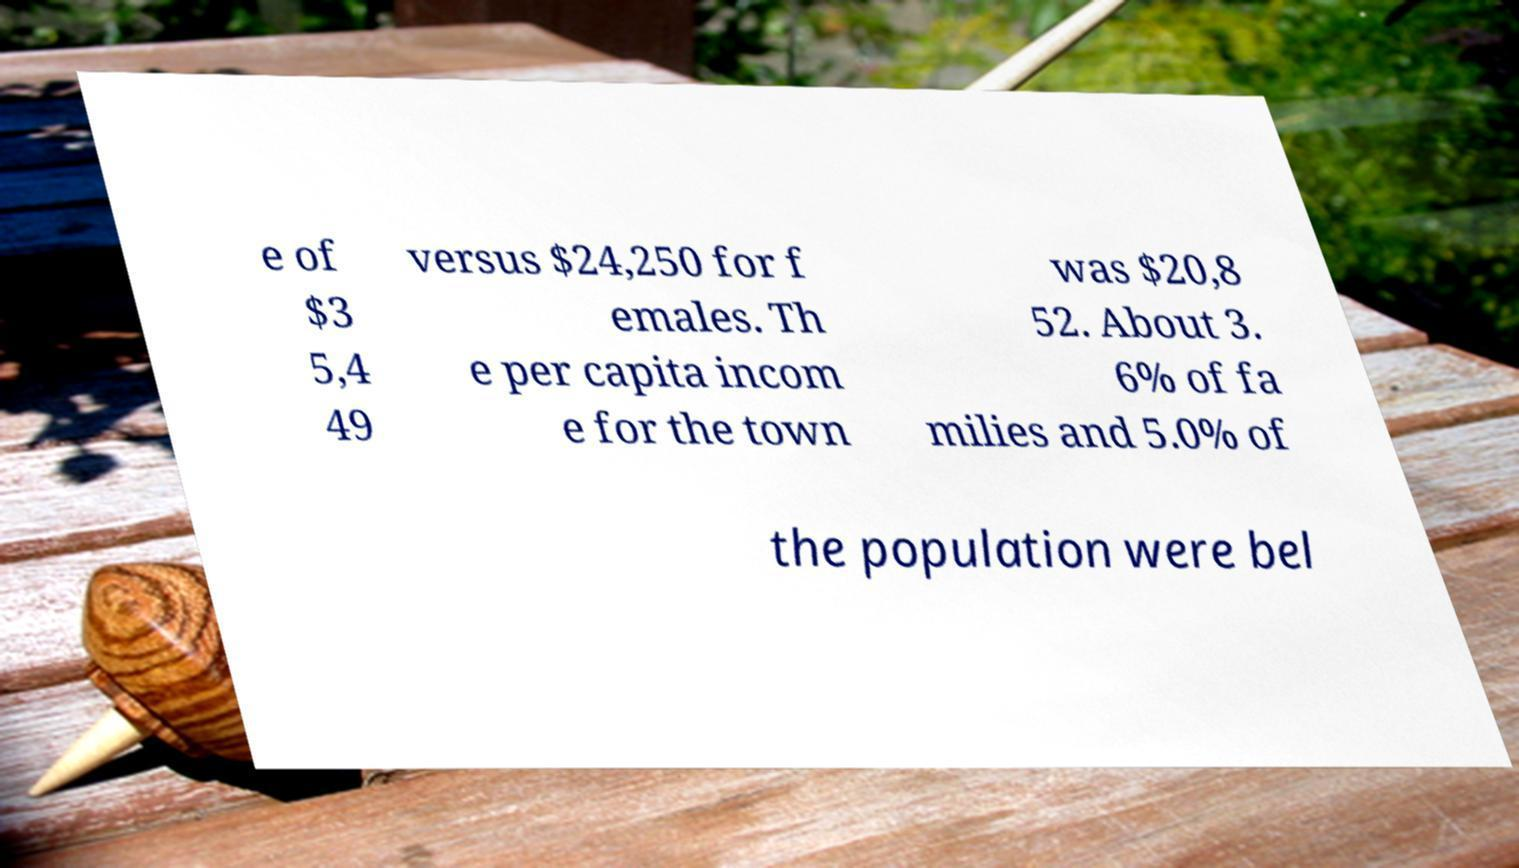Could you extract and type out the text from this image? e of $3 5,4 49 versus $24,250 for f emales. Th e per capita incom e for the town was $20,8 52. About 3. 6% of fa milies and 5.0% of the population were bel 